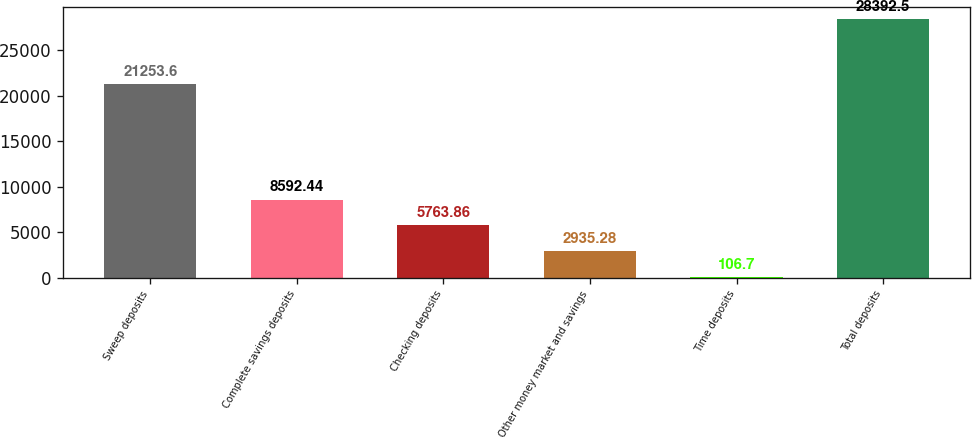Convert chart to OTSL. <chart><loc_0><loc_0><loc_500><loc_500><bar_chart><fcel>Sweep deposits<fcel>Complete savings deposits<fcel>Checking deposits<fcel>Other money market and savings<fcel>Time deposits<fcel>Total deposits<nl><fcel>21253.6<fcel>8592.44<fcel>5763.86<fcel>2935.28<fcel>106.7<fcel>28392.5<nl></chart> 